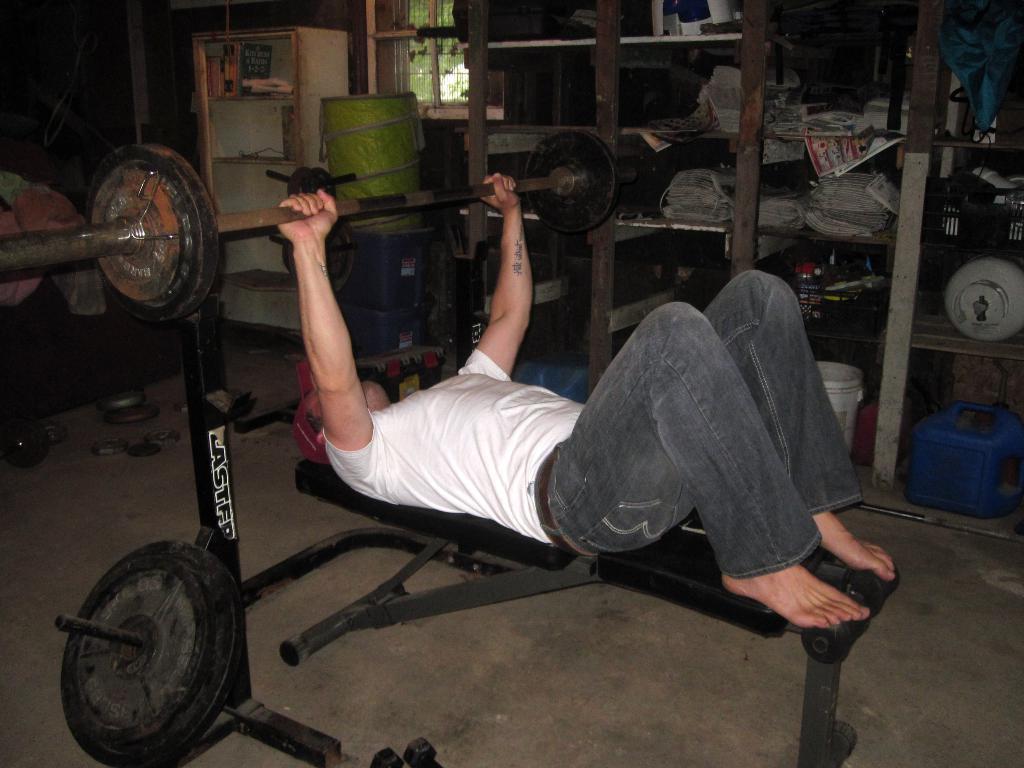Please provide a concise description of this image. In this image we can see a person doing exercise on the machine which is placed on the floor. In addition to this we can see objects that are placed in the cup boards, windows and trees. 